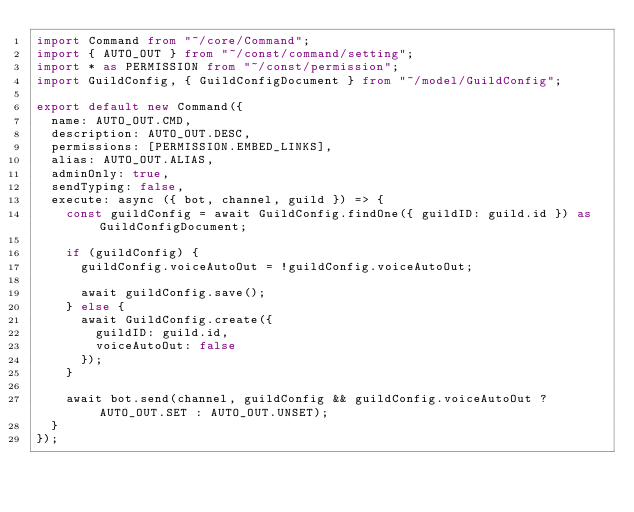<code> <loc_0><loc_0><loc_500><loc_500><_TypeScript_>import Command from "~/core/Command";
import { AUTO_OUT } from "~/const/command/setting";
import * as PERMISSION from "~/const/permission";
import GuildConfig, { GuildConfigDocument } from "~/model/GuildConfig";

export default new Command({
  name: AUTO_OUT.CMD,
  description: AUTO_OUT.DESC,
  permissions: [PERMISSION.EMBED_LINKS],
  alias: AUTO_OUT.ALIAS,
  adminOnly: true,
  sendTyping: false,
  execute: async ({ bot, channel, guild }) => {
    const guildConfig = await GuildConfig.findOne({ guildID: guild.id }) as GuildConfigDocument;

    if (guildConfig) {
      guildConfig.voiceAutoOut = !guildConfig.voiceAutoOut;

      await guildConfig.save();
    } else {
      await GuildConfig.create({
        guildID: guild.id,
        voiceAutoOut: false
      });
    }

    await bot.send(channel, guildConfig && guildConfig.voiceAutoOut ? AUTO_OUT.SET : AUTO_OUT.UNSET);
  }
});
</code> 